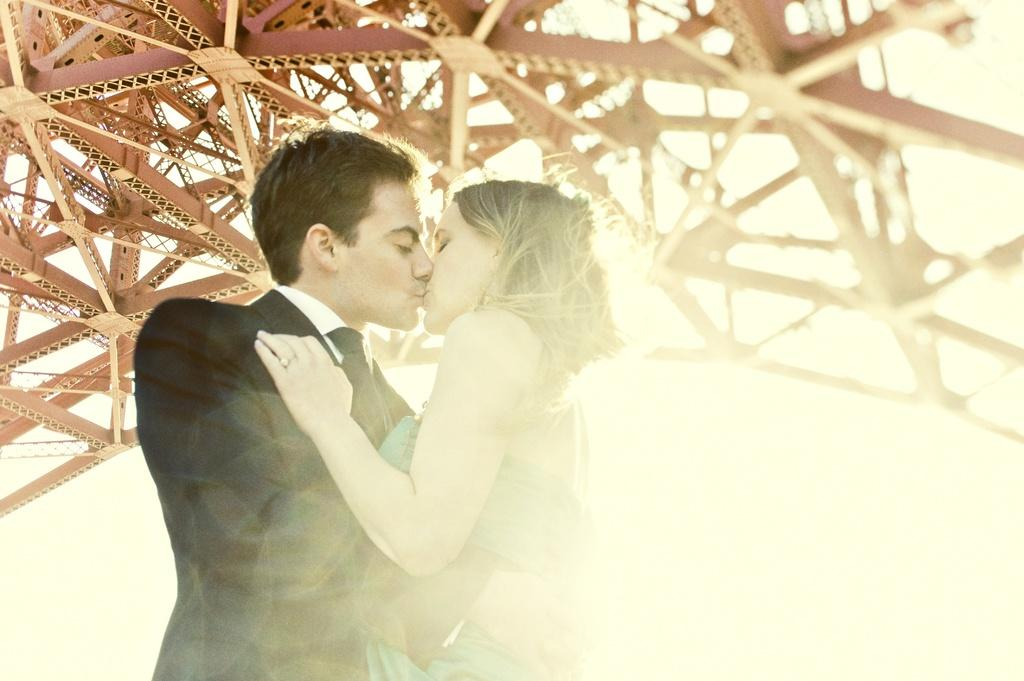How many people are in the image? There are two people in the image, a man and a woman. What are the man and woman doing in the image? The man and woman are kissing in the image. What can be seen at the top of the image? There are metal rods at the top of the image. What is the man wearing in the image? The man is wearing a suit in the image. What type of fruit is the man holding in the image? There is no fruit present in the image; the man is wearing a suit and kissing the woman. 